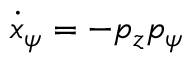Convert formula to latex. <formula><loc_0><loc_0><loc_500><loc_500>\dot { x } _ { \psi } = - p _ { z } p _ { \psi }</formula> 